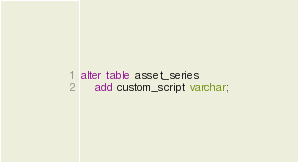<code> <loc_0><loc_0><loc_500><loc_500><_SQL_>alter table asset_series
    add custom_script varchar;
</code> 